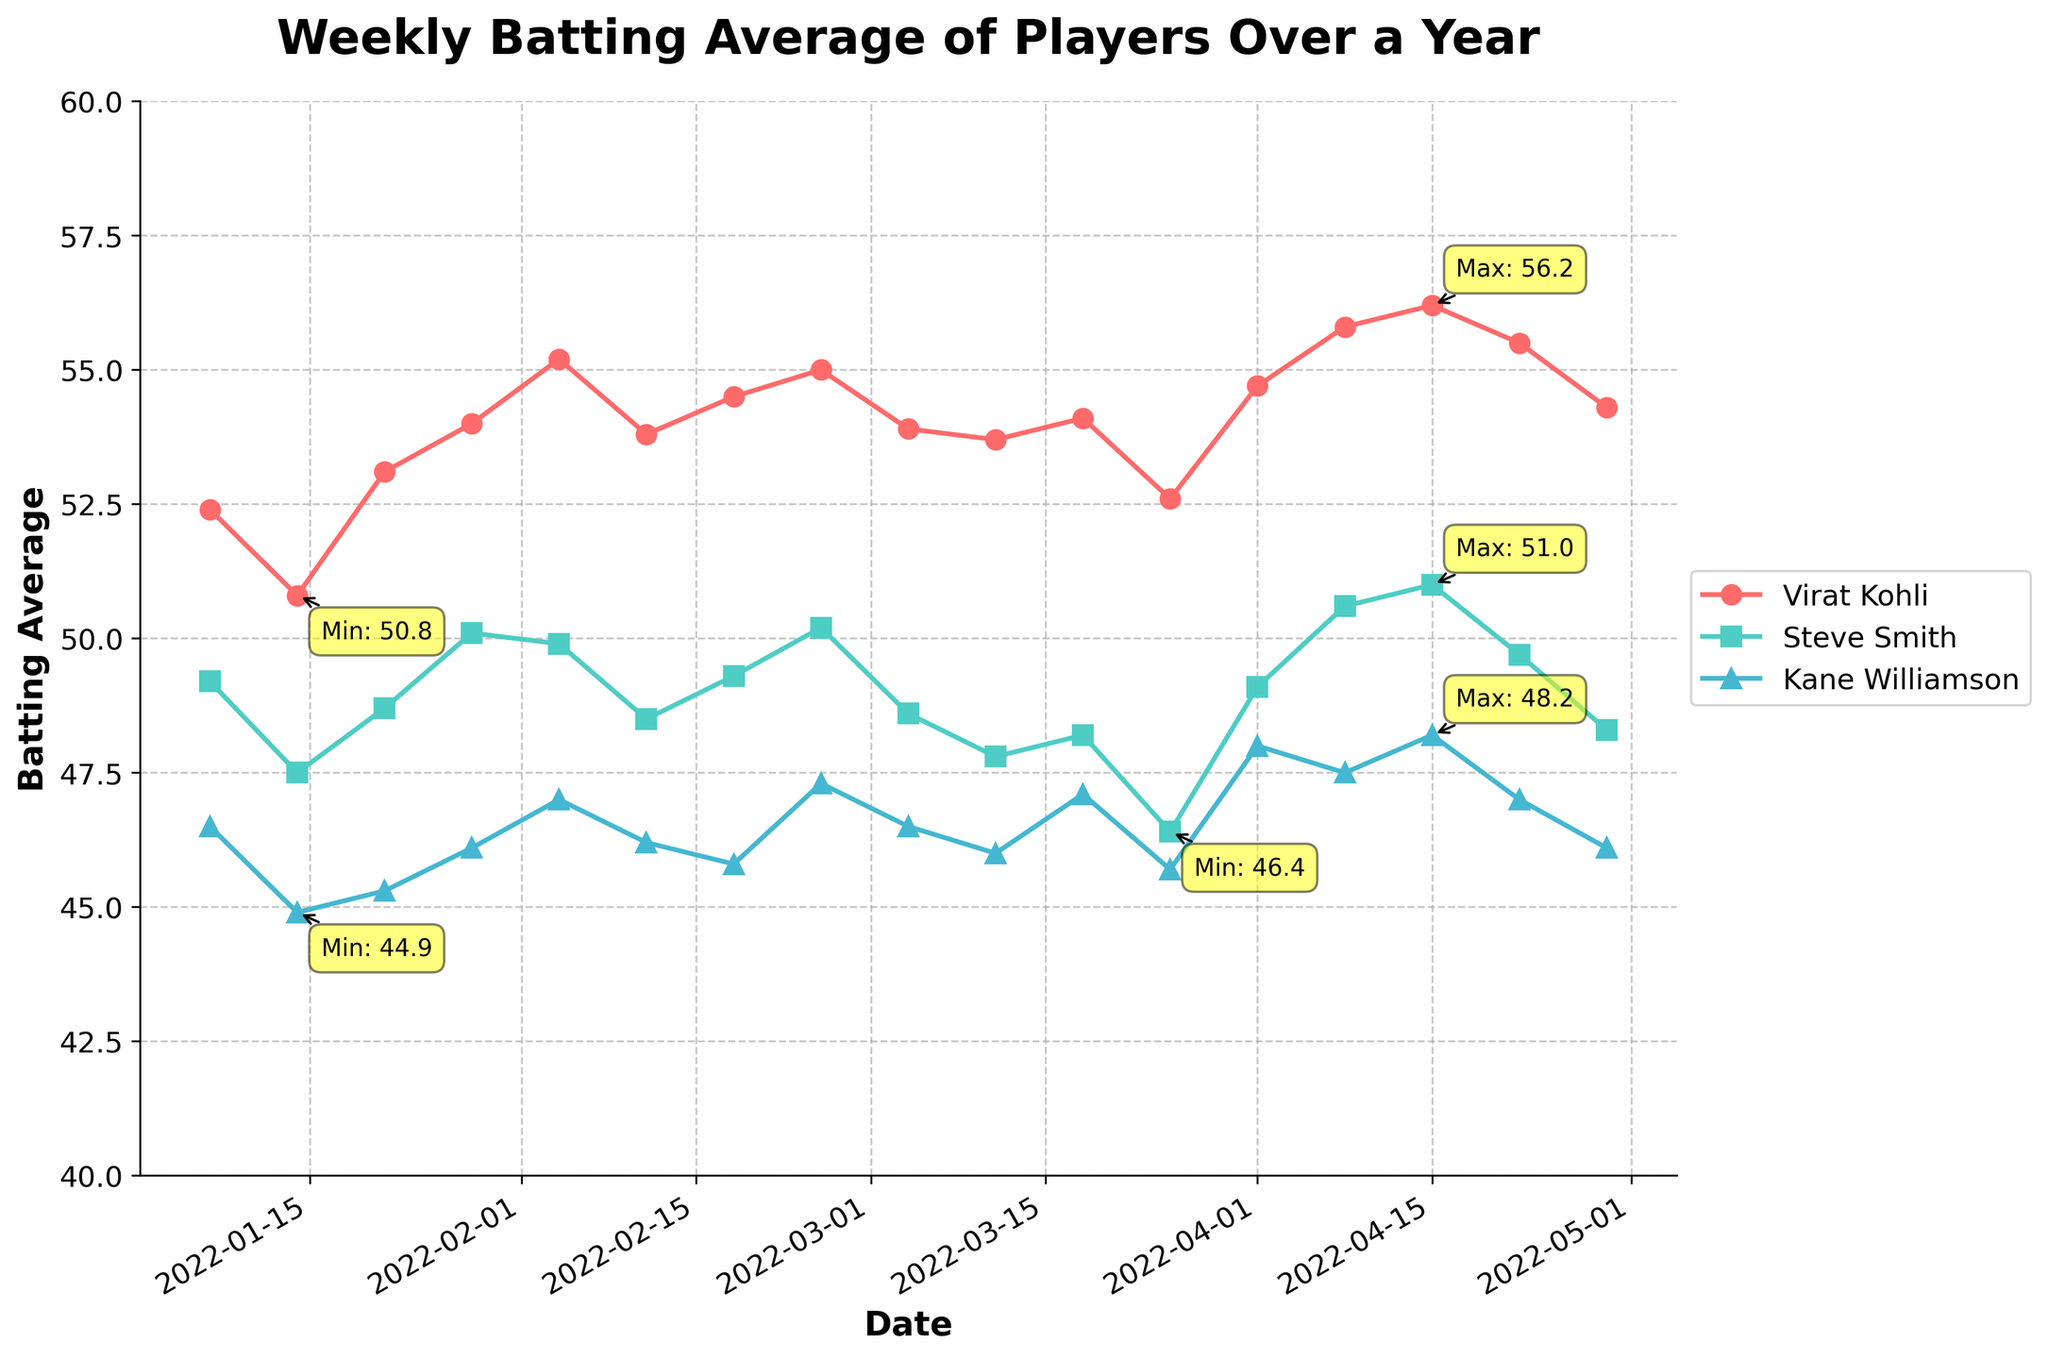What is the title of the plot? The title is displayed at the top center of the plot in bold font.
Answer: Weekly Batting Average of Players Over a Year From which player is the color red used in the plot? Virat Kohli's data line is represented in red color, indicated on the legend to the right of the plot.
Answer: Virat Kohli Which player had the lowest batting average, and when did it occur? Kane Williamson had the lowest batting average on 2022-03-25. This is observed from the annotated "Min: 45.7".
Answer: Kane Williamson, 2022-03-25 Did Steve Smith ever surpass a batting average of 50? Yes, Steve Smith surpassed a batting average of 50 on 2022-02-25 and again on 2022-04-08. This is visible in the plot where the line for Steve Smith crosses the 50 mark.
Answer: Yes What is the trend for Virat Kohli's batting average from January to April? The trend displays an overall increase in Virat Kohli's batting average from January to April. Initially, there are some fluctuations, but the general direction shows growth.
Answer: Increasing trend What is the highest batting average achieved by Virat Kohli, and in which week did it occur? The highest batting average achieved by Virat Kohli is 56.2, which occurred on 2022-04-15. This is indicated by the annotation "Max: 56.2" on the plot.
Answer: 56.2, 2022-04-15 Which player shows the most stability in their batting average over the plot period? Steve Smith shows the most stable batting average over the period, with relatively smaller fluctuations as compared to the other players. His average stays within a narrow range.
Answer: Steve Smith What was the average batting average for Kane Williamson in February? To calculate the average for February:
(47.0 [Feb 4] + 46.2 [Feb 11] + 45.8 [Feb 18] + 47.3 [Feb 25]) / 4. Therefore, (47.0 + 46.2 + 45.8 + 47.3) / 4 = 46.575
Answer: 46.575 Which player had a significant drop in their batting average in any week? Steve Smith had a noticeable drop in his batting average around 2022-03-25, where it decreased to 46.4 from 48.2.
Answer: Steve Smith 